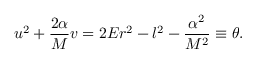Convert formula to latex. <formula><loc_0><loc_0><loc_500><loc_500>u ^ { 2 } + \frac { 2 \alpha } { M } v = 2 E r ^ { 2 } - l ^ { 2 } - \frac { \alpha ^ { 2 } } { M ^ { 2 } } \equiv \theta .</formula> 